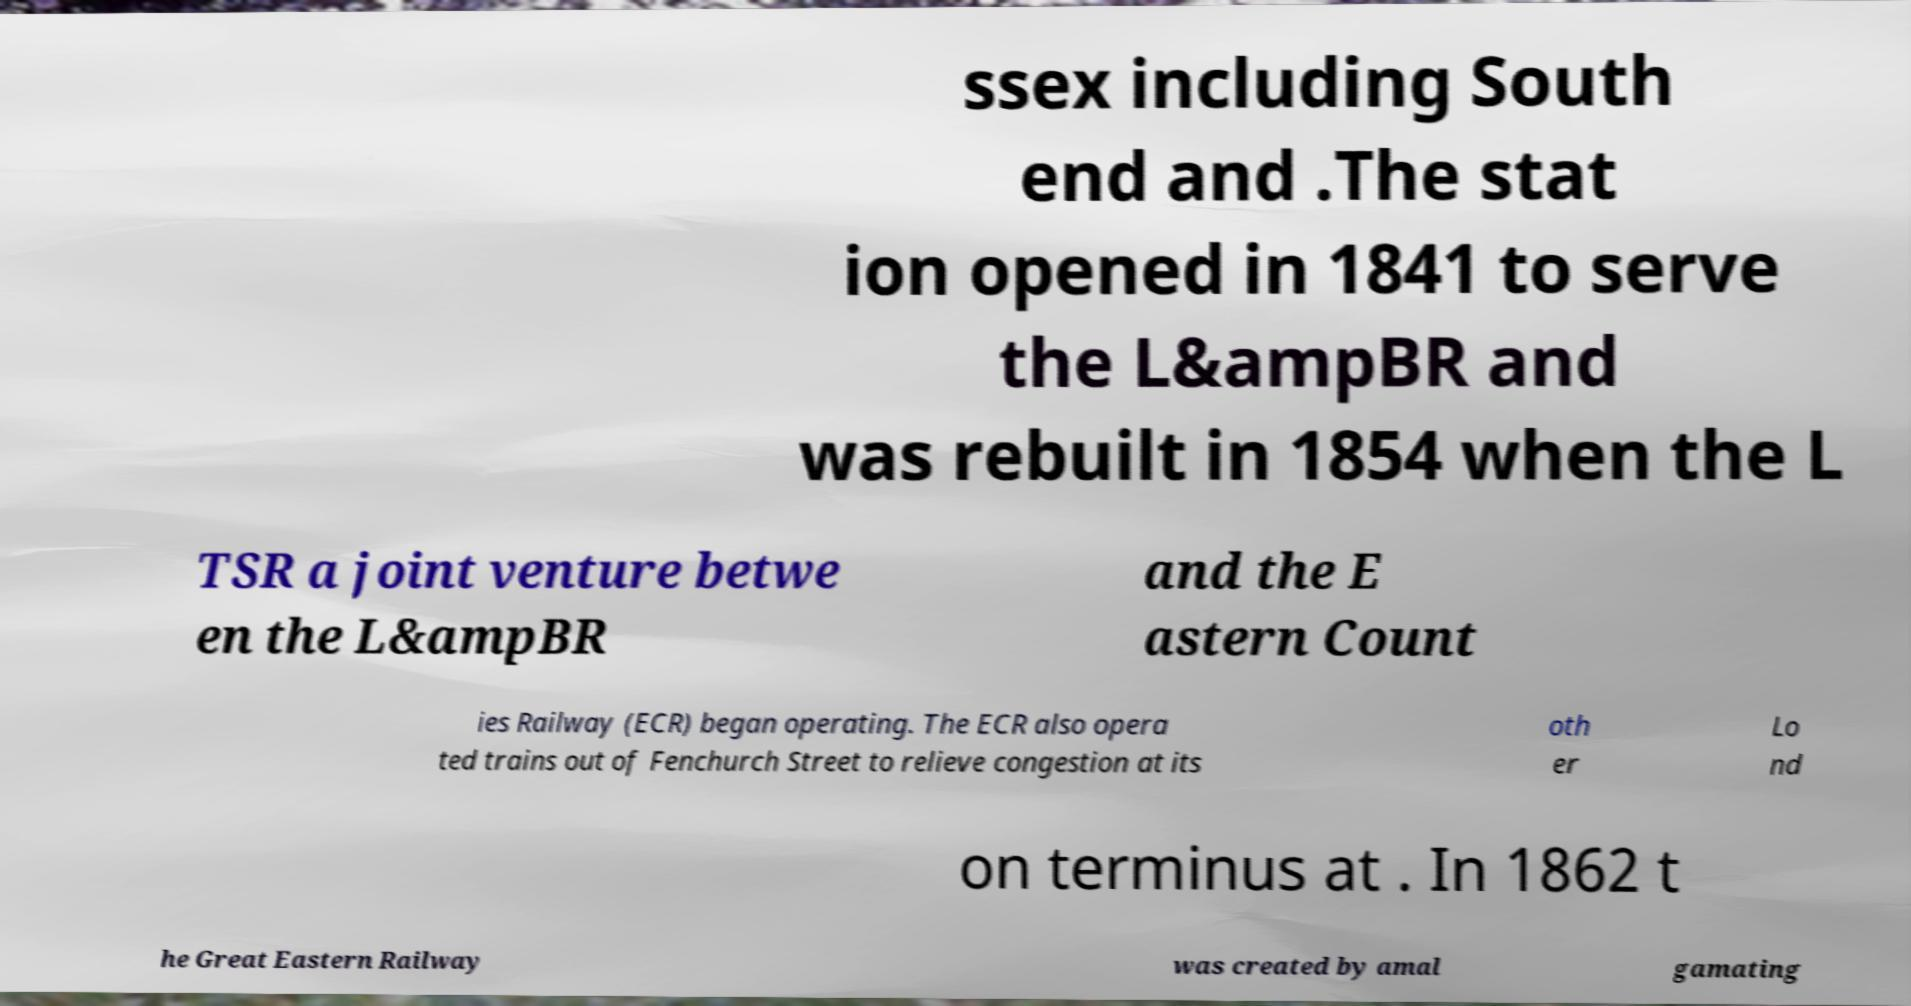Can you accurately transcribe the text from the provided image for me? ssex including South end and .The stat ion opened in 1841 to serve the L&ampBR and was rebuilt in 1854 when the L TSR a joint venture betwe en the L&ampBR and the E astern Count ies Railway (ECR) began operating. The ECR also opera ted trains out of Fenchurch Street to relieve congestion at its oth er Lo nd on terminus at . In 1862 t he Great Eastern Railway was created by amal gamating 